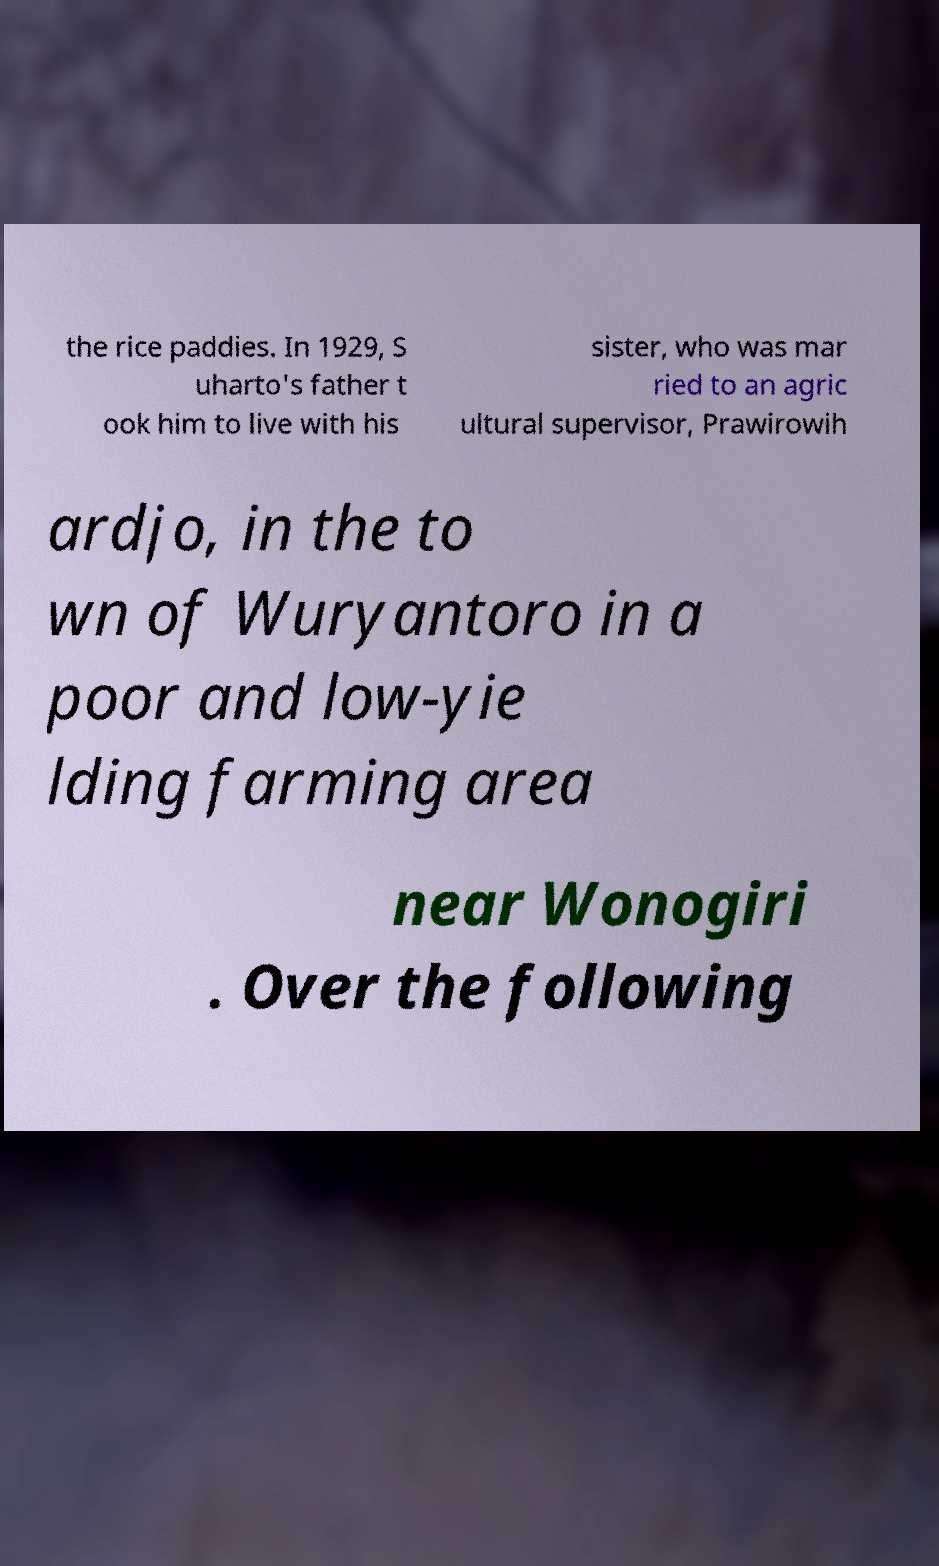Please read and relay the text visible in this image. What does it say? the rice paddies. In 1929, S uharto's father t ook him to live with his sister, who was mar ried to an agric ultural supervisor, Prawirowih ardjo, in the to wn of Wuryantoro in a poor and low-yie lding farming area near Wonogiri . Over the following 